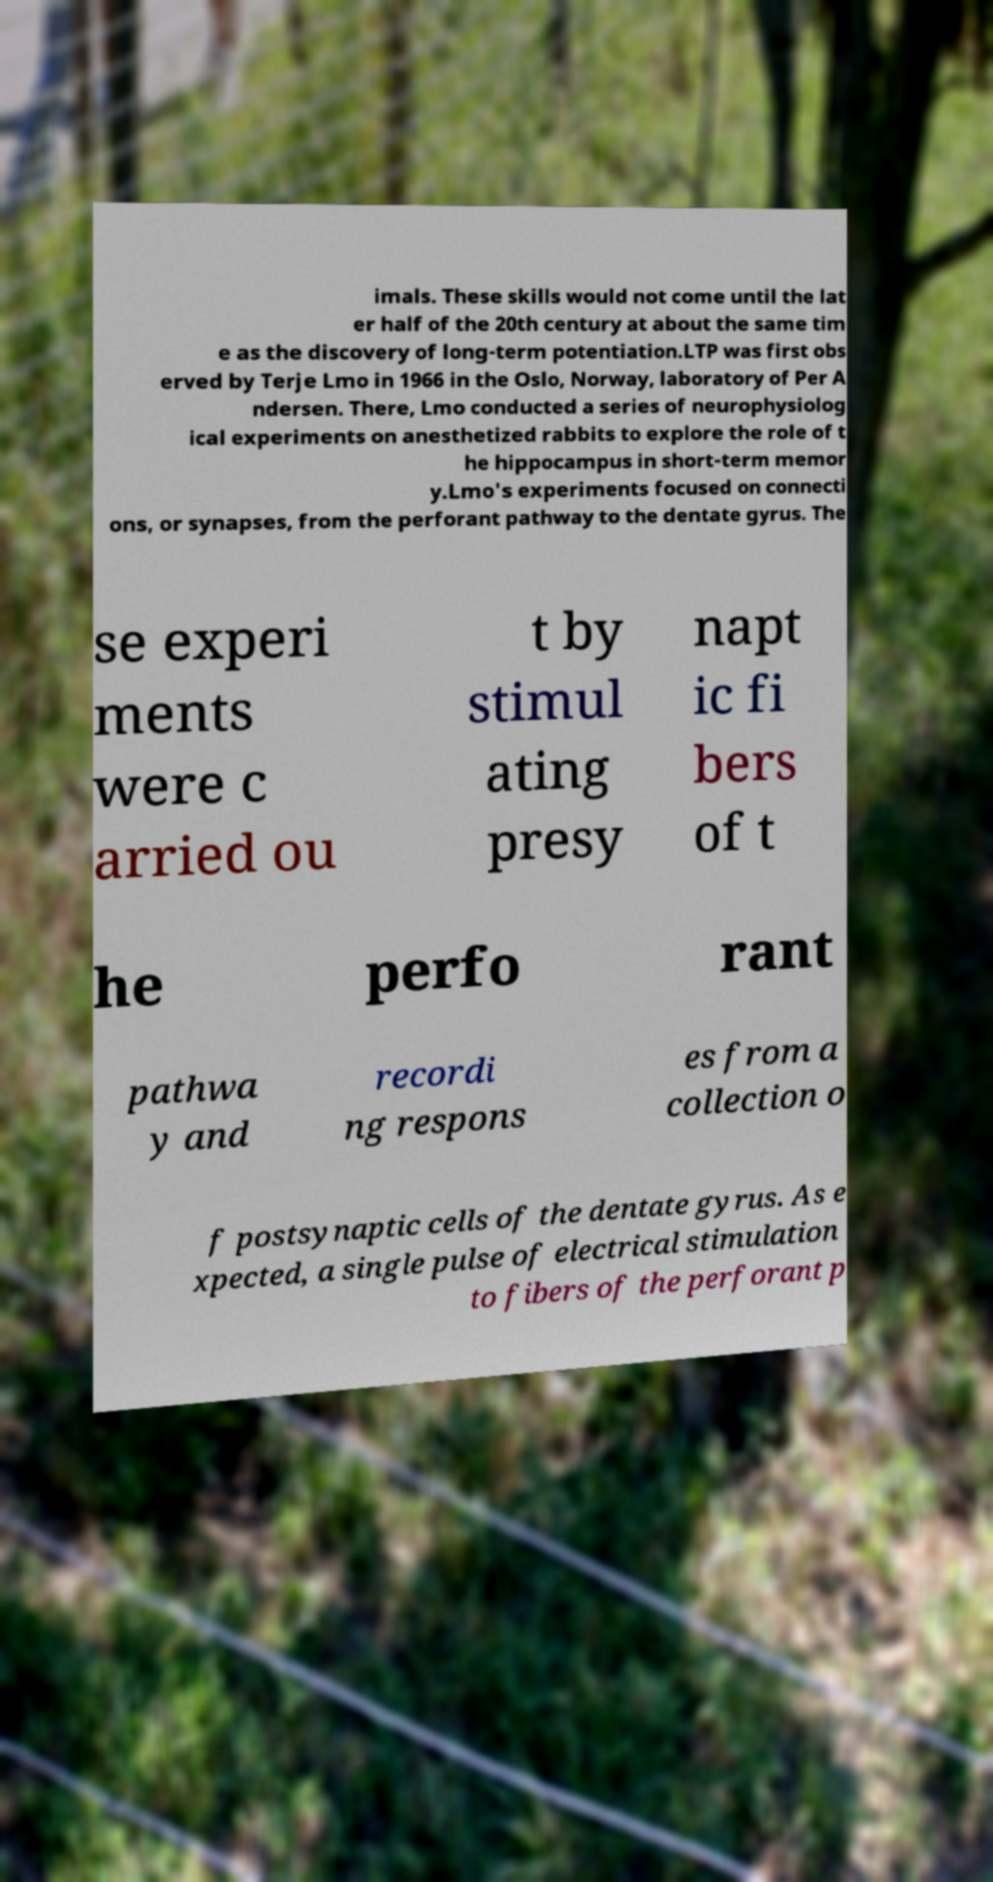I need the written content from this picture converted into text. Can you do that? imals. These skills would not come until the lat er half of the 20th century at about the same tim e as the discovery of long-term potentiation.LTP was first obs erved by Terje Lmo in 1966 in the Oslo, Norway, laboratory of Per A ndersen. There, Lmo conducted a series of neurophysiolog ical experiments on anesthetized rabbits to explore the role of t he hippocampus in short-term memor y.Lmo's experiments focused on connecti ons, or synapses, from the perforant pathway to the dentate gyrus. The se experi ments were c arried ou t by stimul ating presy napt ic fi bers of t he perfo rant pathwa y and recordi ng respons es from a collection o f postsynaptic cells of the dentate gyrus. As e xpected, a single pulse of electrical stimulation to fibers of the perforant p 